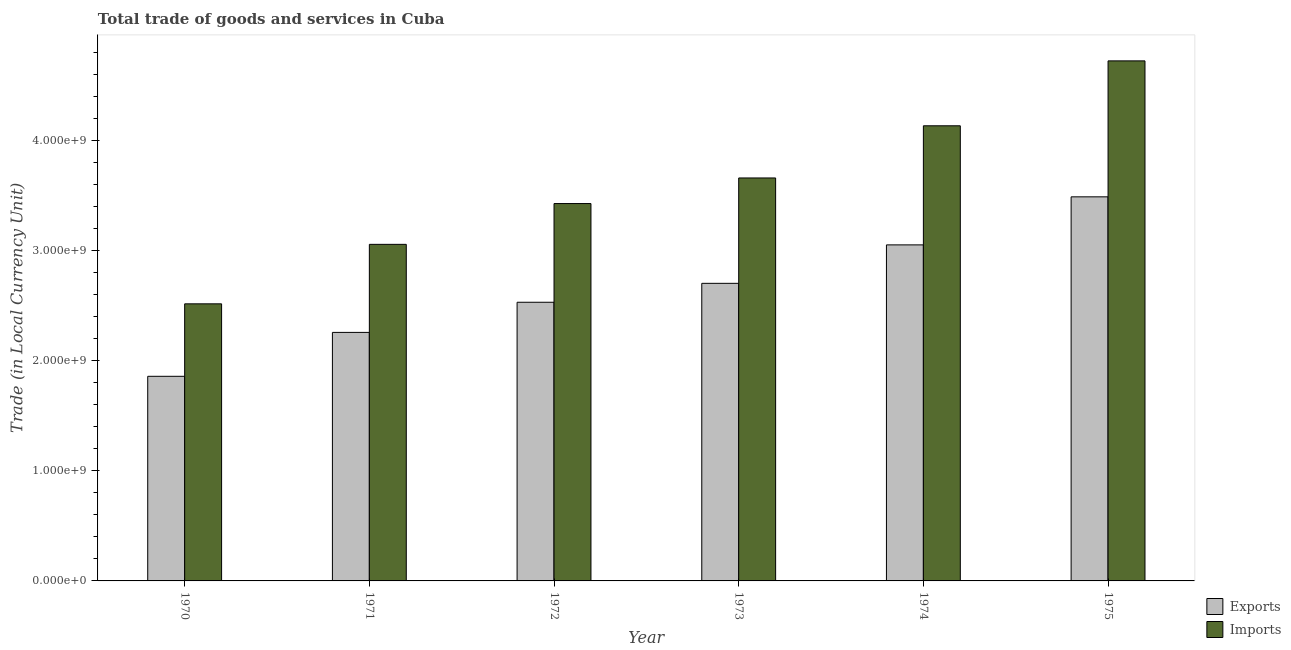How many different coloured bars are there?
Your answer should be compact. 2. How many groups of bars are there?
Your answer should be very brief. 6. How many bars are there on the 3rd tick from the left?
Give a very brief answer. 2. How many bars are there on the 6th tick from the right?
Your answer should be compact. 2. What is the label of the 6th group of bars from the left?
Provide a short and direct response. 1975. What is the imports of goods and services in 1973?
Make the answer very short. 3.66e+09. Across all years, what is the maximum export of goods and services?
Offer a very short reply. 3.49e+09. Across all years, what is the minimum export of goods and services?
Offer a terse response. 1.86e+09. In which year was the imports of goods and services maximum?
Your answer should be very brief. 1975. In which year was the export of goods and services minimum?
Ensure brevity in your answer.  1970. What is the total imports of goods and services in the graph?
Give a very brief answer. 2.15e+1. What is the difference between the export of goods and services in 1973 and that in 1975?
Offer a very short reply. -7.85e+08. What is the difference between the imports of goods and services in 1975 and the export of goods and services in 1970?
Provide a short and direct response. 2.21e+09. What is the average export of goods and services per year?
Your answer should be very brief. 2.65e+09. In the year 1974, what is the difference between the export of goods and services and imports of goods and services?
Provide a short and direct response. 0. In how many years, is the imports of goods and services greater than 2000000000 LCU?
Keep it short and to the point. 6. What is the ratio of the imports of goods and services in 1973 to that in 1975?
Give a very brief answer. 0.77. Is the export of goods and services in 1970 less than that in 1975?
Your response must be concise. Yes. What is the difference between the highest and the second highest imports of goods and services?
Provide a succinct answer. 5.89e+08. What is the difference between the highest and the lowest imports of goods and services?
Your answer should be compact. 2.21e+09. In how many years, is the export of goods and services greater than the average export of goods and services taken over all years?
Offer a terse response. 3. Is the sum of the imports of goods and services in 1972 and 1975 greater than the maximum export of goods and services across all years?
Your answer should be very brief. Yes. What does the 2nd bar from the left in 1974 represents?
Give a very brief answer. Imports. What does the 1st bar from the right in 1973 represents?
Provide a short and direct response. Imports. How many bars are there?
Ensure brevity in your answer.  12. How many years are there in the graph?
Give a very brief answer. 6. Are the values on the major ticks of Y-axis written in scientific E-notation?
Give a very brief answer. Yes. Does the graph contain grids?
Your response must be concise. No. Where does the legend appear in the graph?
Your response must be concise. Bottom right. How many legend labels are there?
Make the answer very short. 2. What is the title of the graph?
Provide a short and direct response. Total trade of goods and services in Cuba. What is the label or title of the Y-axis?
Your answer should be very brief. Trade (in Local Currency Unit). What is the Trade (in Local Currency Unit) of Exports in 1970?
Your answer should be very brief. 1.86e+09. What is the Trade (in Local Currency Unit) in Imports in 1970?
Your answer should be very brief. 2.52e+09. What is the Trade (in Local Currency Unit) in Exports in 1971?
Provide a short and direct response. 2.26e+09. What is the Trade (in Local Currency Unit) of Imports in 1971?
Your response must be concise. 3.06e+09. What is the Trade (in Local Currency Unit) of Exports in 1972?
Ensure brevity in your answer.  2.53e+09. What is the Trade (in Local Currency Unit) of Imports in 1972?
Offer a very short reply. 3.43e+09. What is the Trade (in Local Currency Unit) of Exports in 1973?
Your response must be concise. 2.70e+09. What is the Trade (in Local Currency Unit) of Imports in 1973?
Your response must be concise. 3.66e+09. What is the Trade (in Local Currency Unit) of Exports in 1974?
Your answer should be very brief. 3.05e+09. What is the Trade (in Local Currency Unit) in Imports in 1974?
Provide a succinct answer. 4.13e+09. What is the Trade (in Local Currency Unit) in Exports in 1975?
Your answer should be very brief. 3.49e+09. What is the Trade (in Local Currency Unit) of Imports in 1975?
Offer a terse response. 4.72e+09. Across all years, what is the maximum Trade (in Local Currency Unit) in Exports?
Give a very brief answer. 3.49e+09. Across all years, what is the maximum Trade (in Local Currency Unit) in Imports?
Keep it short and to the point. 4.72e+09. Across all years, what is the minimum Trade (in Local Currency Unit) in Exports?
Offer a terse response. 1.86e+09. Across all years, what is the minimum Trade (in Local Currency Unit) in Imports?
Offer a very short reply. 2.52e+09. What is the total Trade (in Local Currency Unit) in Exports in the graph?
Provide a succinct answer. 1.59e+1. What is the total Trade (in Local Currency Unit) in Imports in the graph?
Give a very brief answer. 2.15e+1. What is the difference between the Trade (in Local Currency Unit) of Exports in 1970 and that in 1971?
Offer a very short reply. -3.99e+08. What is the difference between the Trade (in Local Currency Unit) in Imports in 1970 and that in 1971?
Offer a terse response. -5.40e+08. What is the difference between the Trade (in Local Currency Unit) of Exports in 1970 and that in 1972?
Provide a succinct answer. -6.72e+08. What is the difference between the Trade (in Local Currency Unit) of Imports in 1970 and that in 1972?
Offer a very short reply. -9.10e+08. What is the difference between the Trade (in Local Currency Unit) in Exports in 1970 and that in 1973?
Provide a short and direct response. -8.44e+08. What is the difference between the Trade (in Local Currency Unit) of Imports in 1970 and that in 1973?
Ensure brevity in your answer.  -1.14e+09. What is the difference between the Trade (in Local Currency Unit) of Exports in 1970 and that in 1974?
Your answer should be very brief. -1.19e+09. What is the difference between the Trade (in Local Currency Unit) in Imports in 1970 and that in 1974?
Offer a very short reply. -1.62e+09. What is the difference between the Trade (in Local Currency Unit) in Exports in 1970 and that in 1975?
Offer a terse response. -1.63e+09. What is the difference between the Trade (in Local Currency Unit) of Imports in 1970 and that in 1975?
Give a very brief answer. -2.21e+09. What is the difference between the Trade (in Local Currency Unit) of Exports in 1971 and that in 1972?
Make the answer very short. -2.73e+08. What is the difference between the Trade (in Local Currency Unit) of Imports in 1971 and that in 1972?
Make the answer very short. -3.70e+08. What is the difference between the Trade (in Local Currency Unit) of Exports in 1971 and that in 1973?
Your response must be concise. -4.45e+08. What is the difference between the Trade (in Local Currency Unit) in Imports in 1971 and that in 1973?
Make the answer very short. -6.03e+08. What is the difference between the Trade (in Local Currency Unit) of Exports in 1971 and that in 1974?
Make the answer very short. -7.94e+08. What is the difference between the Trade (in Local Currency Unit) of Imports in 1971 and that in 1974?
Give a very brief answer. -1.08e+09. What is the difference between the Trade (in Local Currency Unit) of Exports in 1971 and that in 1975?
Your answer should be very brief. -1.23e+09. What is the difference between the Trade (in Local Currency Unit) in Imports in 1971 and that in 1975?
Provide a short and direct response. -1.67e+09. What is the difference between the Trade (in Local Currency Unit) of Exports in 1972 and that in 1973?
Provide a short and direct response. -1.72e+08. What is the difference between the Trade (in Local Currency Unit) in Imports in 1972 and that in 1973?
Provide a short and direct response. -2.32e+08. What is the difference between the Trade (in Local Currency Unit) of Exports in 1972 and that in 1974?
Keep it short and to the point. -5.21e+08. What is the difference between the Trade (in Local Currency Unit) in Imports in 1972 and that in 1974?
Your answer should be very brief. -7.06e+08. What is the difference between the Trade (in Local Currency Unit) of Exports in 1972 and that in 1975?
Provide a succinct answer. -9.57e+08. What is the difference between the Trade (in Local Currency Unit) of Imports in 1972 and that in 1975?
Provide a short and direct response. -1.30e+09. What is the difference between the Trade (in Local Currency Unit) in Exports in 1973 and that in 1974?
Keep it short and to the point. -3.49e+08. What is the difference between the Trade (in Local Currency Unit) in Imports in 1973 and that in 1974?
Ensure brevity in your answer.  -4.74e+08. What is the difference between the Trade (in Local Currency Unit) in Exports in 1973 and that in 1975?
Make the answer very short. -7.85e+08. What is the difference between the Trade (in Local Currency Unit) in Imports in 1973 and that in 1975?
Provide a short and direct response. -1.06e+09. What is the difference between the Trade (in Local Currency Unit) of Exports in 1974 and that in 1975?
Offer a very short reply. -4.36e+08. What is the difference between the Trade (in Local Currency Unit) of Imports in 1974 and that in 1975?
Your response must be concise. -5.89e+08. What is the difference between the Trade (in Local Currency Unit) of Exports in 1970 and the Trade (in Local Currency Unit) of Imports in 1971?
Your answer should be very brief. -1.20e+09. What is the difference between the Trade (in Local Currency Unit) in Exports in 1970 and the Trade (in Local Currency Unit) in Imports in 1972?
Your answer should be very brief. -1.57e+09. What is the difference between the Trade (in Local Currency Unit) of Exports in 1970 and the Trade (in Local Currency Unit) of Imports in 1973?
Your answer should be compact. -1.80e+09. What is the difference between the Trade (in Local Currency Unit) in Exports in 1970 and the Trade (in Local Currency Unit) in Imports in 1974?
Make the answer very short. -2.27e+09. What is the difference between the Trade (in Local Currency Unit) in Exports in 1970 and the Trade (in Local Currency Unit) in Imports in 1975?
Give a very brief answer. -2.86e+09. What is the difference between the Trade (in Local Currency Unit) in Exports in 1971 and the Trade (in Local Currency Unit) in Imports in 1972?
Your answer should be very brief. -1.17e+09. What is the difference between the Trade (in Local Currency Unit) of Exports in 1971 and the Trade (in Local Currency Unit) of Imports in 1973?
Your answer should be compact. -1.40e+09. What is the difference between the Trade (in Local Currency Unit) in Exports in 1971 and the Trade (in Local Currency Unit) in Imports in 1974?
Provide a succinct answer. -1.88e+09. What is the difference between the Trade (in Local Currency Unit) in Exports in 1971 and the Trade (in Local Currency Unit) in Imports in 1975?
Your answer should be very brief. -2.46e+09. What is the difference between the Trade (in Local Currency Unit) in Exports in 1972 and the Trade (in Local Currency Unit) in Imports in 1973?
Give a very brief answer. -1.13e+09. What is the difference between the Trade (in Local Currency Unit) of Exports in 1972 and the Trade (in Local Currency Unit) of Imports in 1974?
Provide a short and direct response. -1.60e+09. What is the difference between the Trade (in Local Currency Unit) in Exports in 1972 and the Trade (in Local Currency Unit) in Imports in 1975?
Provide a short and direct response. -2.19e+09. What is the difference between the Trade (in Local Currency Unit) of Exports in 1973 and the Trade (in Local Currency Unit) of Imports in 1974?
Provide a succinct answer. -1.43e+09. What is the difference between the Trade (in Local Currency Unit) of Exports in 1973 and the Trade (in Local Currency Unit) of Imports in 1975?
Keep it short and to the point. -2.02e+09. What is the difference between the Trade (in Local Currency Unit) in Exports in 1974 and the Trade (in Local Currency Unit) in Imports in 1975?
Offer a very short reply. -1.67e+09. What is the average Trade (in Local Currency Unit) of Exports per year?
Your response must be concise. 2.65e+09. What is the average Trade (in Local Currency Unit) of Imports per year?
Provide a succinct answer. 3.58e+09. In the year 1970, what is the difference between the Trade (in Local Currency Unit) of Exports and Trade (in Local Currency Unit) of Imports?
Offer a terse response. -6.58e+08. In the year 1971, what is the difference between the Trade (in Local Currency Unit) of Exports and Trade (in Local Currency Unit) of Imports?
Offer a terse response. -7.99e+08. In the year 1972, what is the difference between the Trade (in Local Currency Unit) in Exports and Trade (in Local Currency Unit) in Imports?
Your answer should be very brief. -8.96e+08. In the year 1973, what is the difference between the Trade (in Local Currency Unit) of Exports and Trade (in Local Currency Unit) of Imports?
Your response must be concise. -9.57e+08. In the year 1974, what is the difference between the Trade (in Local Currency Unit) of Exports and Trade (in Local Currency Unit) of Imports?
Your answer should be very brief. -1.08e+09. In the year 1975, what is the difference between the Trade (in Local Currency Unit) in Exports and Trade (in Local Currency Unit) in Imports?
Ensure brevity in your answer.  -1.23e+09. What is the ratio of the Trade (in Local Currency Unit) in Exports in 1970 to that in 1971?
Offer a terse response. 0.82. What is the ratio of the Trade (in Local Currency Unit) in Imports in 1970 to that in 1971?
Your answer should be compact. 0.82. What is the ratio of the Trade (in Local Currency Unit) in Exports in 1970 to that in 1972?
Your answer should be compact. 0.73. What is the ratio of the Trade (in Local Currency Unit) of Imports in 1970 to that in 1972?
Your response must be concise. 0.73. What is the ratio of the Trade (in Local Currency Unit) in Exports in 1970 to that in 1973?
Your answer should be very brief. 0.69. What is the ratio of the Trade (in Local Currency Unit) of Imports in 1970 to that in 1973?
Provide a short and direct response. 0.69. What is the ratio of the Trade (in Local Currency Unit) of Exports in 1970 to that in 1974?
Your response must be concise. 0.61. What is the ratio of the Trade (in Local Currency Unit) in Imports in 1970 to that in 1974?
Offer a terse response. 0.61. What is the ratio of the Trade (in Local Currency Unit) of Exports in 1970 to that in 1975?
Make the answer very short. 0.53. What is the ratio of the Trade (in Local Currency Unit) of Imports in 1970 to that in 1975?
Your answer should be compact. 0.53. What is the ratio of the Trade (in Local Currency Unit) of Exports in 1971 to that in 1972?
Make the answer very short. 0.89. What is the ratio of the Trade (in Local Currency Unit) of Imports in 1971 to that in 1972?
Your answer should be very brief. 0.89. What is the ratio of the Trade (in Local Currency Unit) in Exports in 1971 to that in 1973?
Ensure brevity in your answer.  0.84. What is the ratio of the Trade (in Local Currency Unit) in Imports in 1971 to that in 1973?
Your answer should be very brief. 0.84. What is the ratio of the Trade (in Local Currency Unit) of Exports in 1971 to that in 1974?
Give a very brief answer. 0.74. What is the ratio of the Trade (in Local Currency Unit) of Imports in 1971 to that in 1974?
Give a very brief answer. 0.74. What is the ratio of the Trade (in Local Currency Unit) in Exports in 1971 to that in 1975?
Offer a very short reply. 0.65. What is the ratio of the Trade (in Local Currency Unit) of Imports in 1971 to that in 1975?
Give a very brief answer. 0.65. What is the ratio of the Trade (in Local Currency Unit) in Exports in 1972 to that in 1973?
Provide a short and direct response. 0.94. What is the ratio of the Trade (in Local Currency Unit) of Imports in 1972 to that in 1973?
Ensure brevity in your answer.  0.94. What is the ratio of the Trade (in Local Currency Unit) of Exports in 1972 to that in 1974?
Provide a short and direct response. 0.83. What is the ratio of the Trade (in Local Currency Unit) in Imports in 1972 to that in 1974?
Offer a terse response. 0.83. What is the ratio of the Trade (in Local Currency Unit) of Exports in 1972 to that in 1975?
Give a very brief answer. 0.73. What is the ratio of the Trade (in Local Currency Unit) of Imports in 1972 to that in 1975?
Provide a short and direct response. 0.73. What is the ratio of the Trade (in Local Currency Unit) of Exports in 1973 to that in 1974?
Your answer should be compact. 0.89. What is the ratio of the Trade (in Local Currency Unit) in Imports in 1973 to that in 1974?
Provide a succinct answer. 0.89. What is the ratio of the Trade (in Local Currency Unit) of Exports in 1973 to that in 1975?
Your answer should be very brief. 0.77. What is the ratio of the Trade (in Local Currency Unit) in Imports in 1973 to that in 1975?
Your answer should be compact. 0.77. What is the ratio of the Trade (in Local Currency Unit) of Exports in 1974 to that in 1975?
Provide a short and direct response. 0.87. What is the ratio of the Trade (in Local Currency Unit) in Imports in 1974 to that in 1975?
Offer a terse response. 0.88. What is the difference between the highest and the second highest Trade (in Local Currency Unit) of Exports?
Provide a short and direct response. 4.36e+08. What is the difference between the highest and the second highest Trade (in Local Currency Unit) in Imports?
Provide a succinct answer. 5.89e+08. What is the difference between the highest and the lowest Trade (in Local Currency Unit) in Exports?
Keep it short and to the point. 1.63e+09. What is the difference between the highest and the lowest Trade (in Local Currency Unit) of Imports?
Provide a succinct answer. 2.21e+09. 